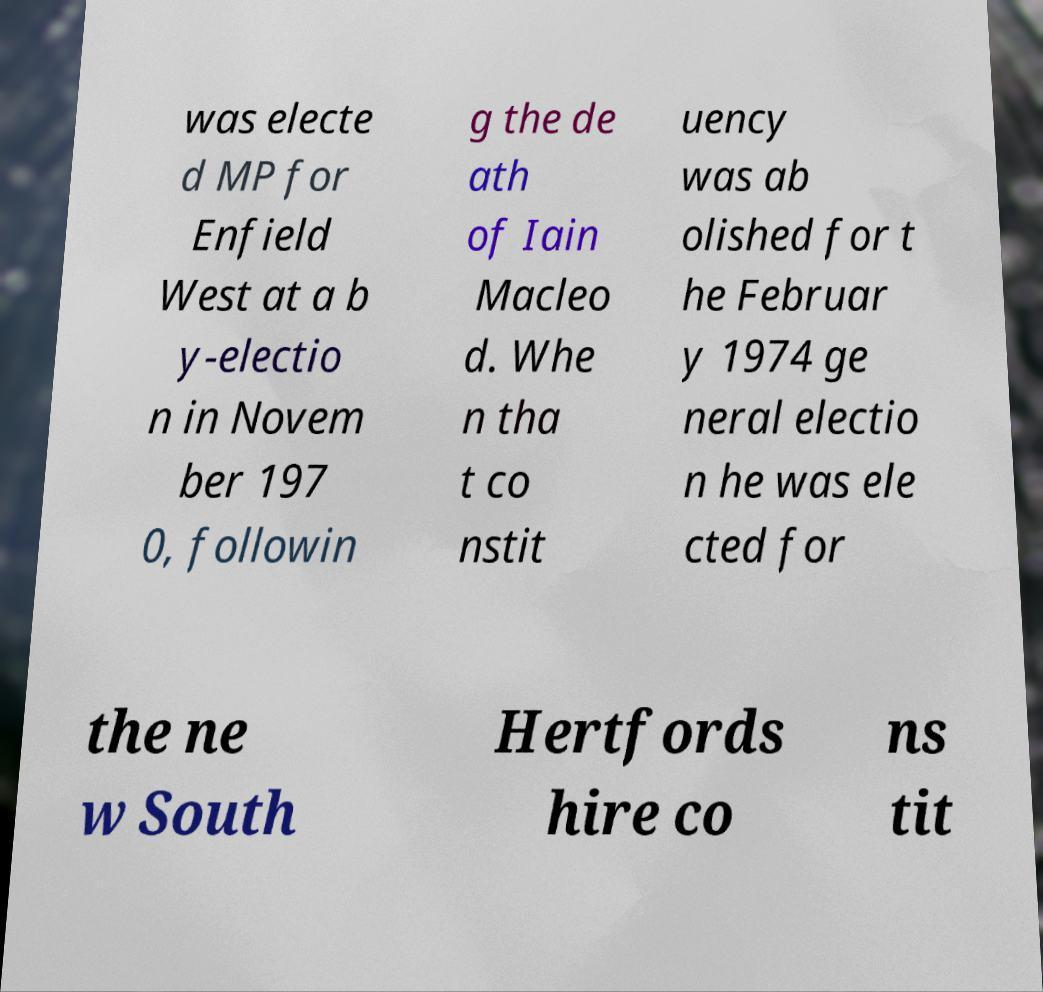For documentation purposes, I need the text within this image transcribed. Could you provide that? was electe d MP for Enfield West at a b y-electio n in Novem ber 197 0, followin g the de ath of Iain Macleo d. Whe n tha t co nstit uency was ab olished for t he Februar y 1974 ge neral electio n he was ele cted for the ne w South Hertfords hire co ns tit 